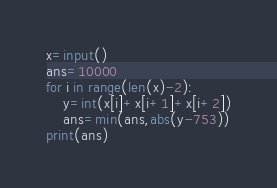Convert code to text. <code><loc_0><loc_0><loc_500><loc_500><_Python_>x=input()
ans=10000
for i in range(len(x)-2):
    y=int(x[i]+x[i+1]+x[i+2])
    ans=min(ans,abs(y-753))
print(ans)</code> 